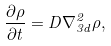<formula> <loc_0><loc_0><loc_500><loc_500>\frac { \partial \rho } { \partial t } = D \nabla ^ { 2 } _ { 3 d } \rho ,</formula> 